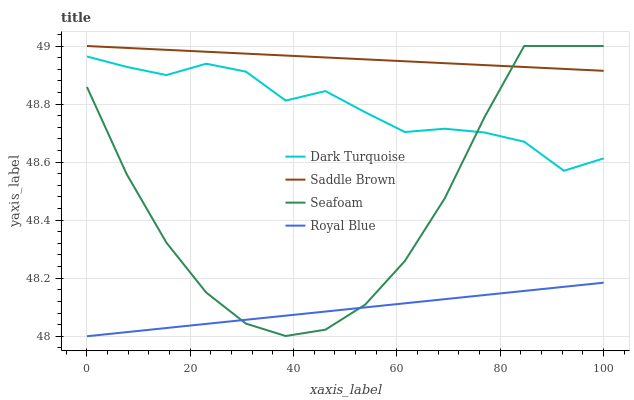Does Saddle Brown have the minimum area under the curve?
Answer yes or no. No. Does Royal Blue have the maximum area under the curve?
Answer yes or no. No. Is Royal Blue the smoothest?
Answer yes or no. No. Is Royal Blue the roughest?
Answer yes or no. No. Does Saddle Brown have the lowest value?
Answer yes or no. No. Does Royal Blue have the highest value?
Answer yes or no. No. Is Royal Blue less than Saddle Brown?
Answer yes or no. Yes. Is Saddle Brown greater than Dark Turquoise?
Answer yes or no. Yes. Does Royal Blue intersect Saddle Brown?
Answer yes or no. No. 